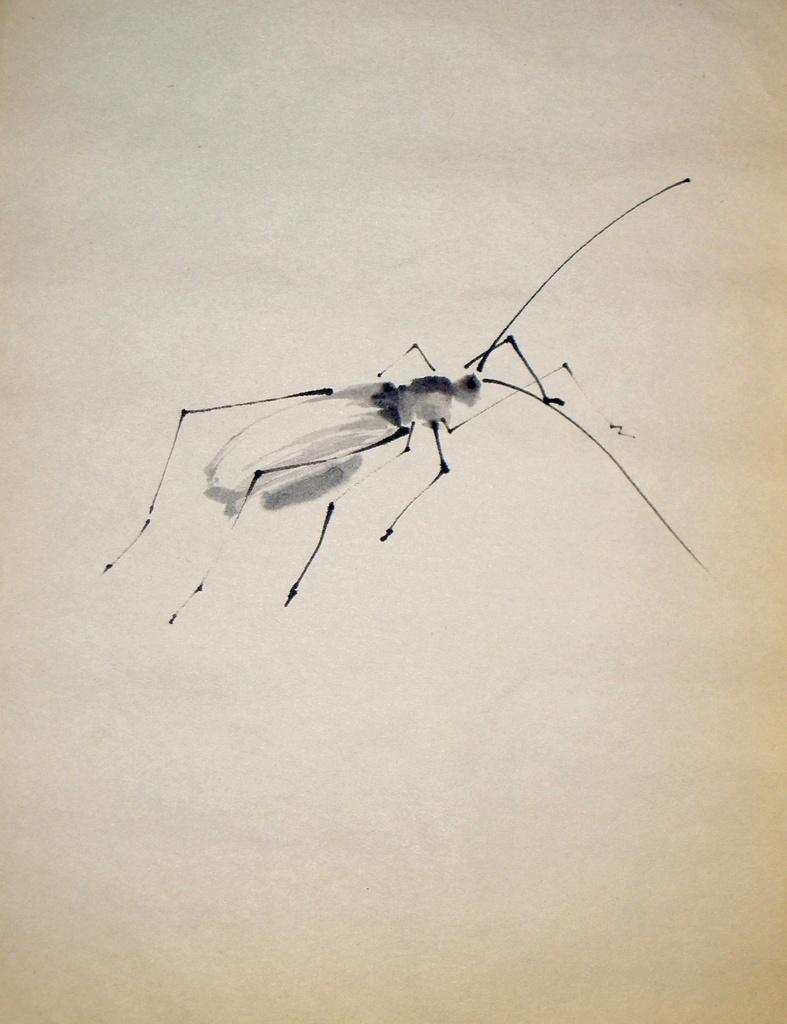What is depicted in the image? There is a drawing of an insect in the image. What is the background of the drawing? The drawing is on a white surface. What type of flower is present in the image? There is no flower present in the image; it features a drawing of an insect on a white surface. 